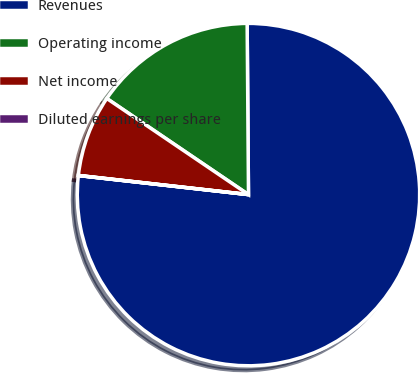Convert chart. <chart><loc_0><loc_0><loc_500><loc_500><pie_chart><fcel>Revenues<fcel>Operating income<fcel>Net income<fcel>Diluted earnings per share<nl><fcel>76.9%<fcel>15.39%<fcel>7.7%<fcel>0.01%<nl></chart> 